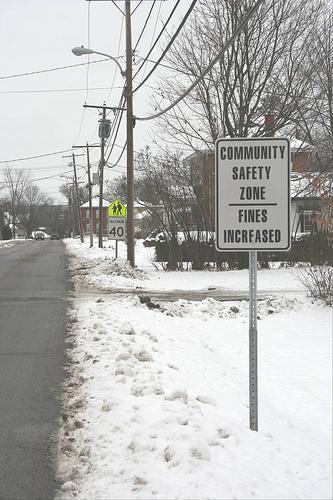How many signs?
Give a very brief answer. 2. 